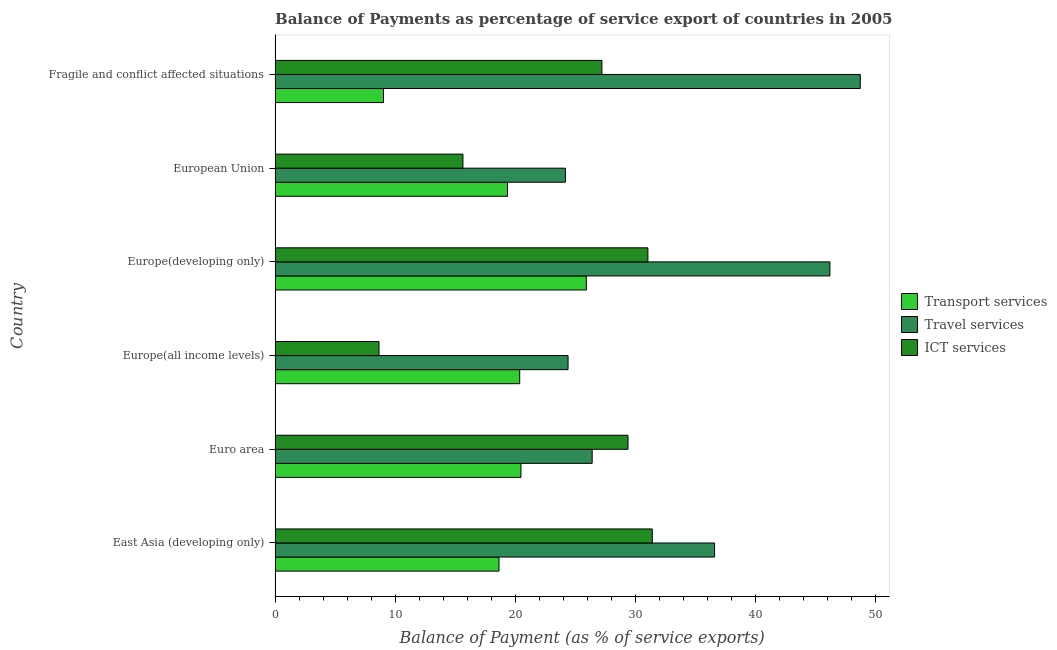How many different coloured bars are there?
Offer a very short reply. 3. How many groups of bars are there?
Give a very brief answer. 6. How many bars are there on the 4th tick from the top?
Your answer should be very brief. 3. How many bars are there on the 4th tick from the bottom?
Provide a short and direct response. 3. What is the label of the 4th group of bars from the top?
Your response must be concise. Europe(all income levels). What is the balance of payment of travel services in European Union?
Provide a succinct answer. 24.19. Across all countries, what is the maximum balance of payment of ict services?
Provide a short and direct response. 31.44. Across all countries, what is the minimum balance of payment of ict services?
Keep it short and to the point. 8.66. In which country was the balance of payment of travel services maximum?
Ensure brevity in your answer.  Fragile and conflict affected situations. In which country was the balance of payment of ict services minimum?
Your answer should be very brief. Europe(all income levels). What is the total balance of payment of transport services in the graph?
Your response must be concise. 113.88. What is the difference between the balance of payment of ict services in Euro area and that in Fragile and conflict affected situations?
Your response must be concise. 2.17. What is the difference between the balance of payment of ict services in Euro area and the balance of payment of travel services in Fragile and conflict affected situations?
Your answer should be very brief. -19.36. What is the average balance of payment of ict services per country?
Ensure brevity in your answer.  23.91. What is the difference between the balance of payment of ict services and balance of payment of transport services in Europe(developing only)?
Your response must be concise. 5.13. In how many countries, is the balance of payment of travel services greater than 10 %?
Ensure brevity in your answer.  6. What is the ratio of the balance of payment of ict services in Euro area to that in Fragile and conflict affected situations?
Offer a terse response. 1.08. Is the balance of payment of transport services in Euro area less than that in Fragile and conflict affected situations?
Keep it short and to the point. No. What is the difference between the highest and the second highest balance of payment of travel services?
Offer a very short reply. 2.53. What is the difference between the highest and the lowest balance of payment of ict services?
Offer a very short reply. 22.77. Is the sum of the balance of payment of travel services in Euro area and Fragile and conflict affected situations greater than the maximum balance of payment of ict services across all countries?
Make the answer very short. Yes. What does the 1st bar from the top in Europe(all income levels) represents?
Give a very brief answer. ICT services. What does the 1st bar from the bottom in Europe(all income levels) represents?
Keep it short and to the point. Transport services. Is it the case that in every country, the sum of the balance of payment of transport services and balance of payment of travel services is greater than the balance of payment of ict services?
Your response must be concise. Yes. Are all the bars in the graph horizontal?
Your answer should be very brief. Yes. What is the difference between two consecutive major ticks on the X-axis?
Your answer should be very brief. 10. Does the graph contain any zero values?
Provide a short and direct response. No. Where does the legend appear in the graph?
Your answer should be compact. Center right. How many legend labels are there?
Your response must be concise. 3. How are the legend labels stacked?
Offer a terse response. Vertical. What is the title of the graph?
Your response must be concise. Balance of Payments as percentage of service export of countries in 2005. Does "Primary" appear as one of the legend labels in the graph?
Give a very brief answer. No. What is the label or title of the X-axis?
Give a very brief answer. Balance of Payment (as % of service exports). What is the Balance of Payment (as % of service exports) in Transport services in East Asia (developing only)?
Make the answer very short. 18.66. What is the Balance of Payment (as % of service exports) in Travel services in East Asia (developing only)?
Keep it short and to the point. 36.63. What is the Balance of Payment (as % of service exports) in ICT services in East Asia (developing only)?
Your answer should be very brief. 31.44. What is the Balance of Payment (as % of service exports) of Transport services in Euro area?
Ensure brevity in your answer.  20.49. What is the Balance of Payment (as % of service exports) in Travel services in Euro area?
Your response must be concise. 26.42. What is the Balance of Payment (as % of service exports) in ICT services in Euro area?
Your answer should be very brief. 29.41. What is the Balance of Payment (as % of service exports) in Transport services in Europe(all income levels)?
Your response must be concise. 20.39. What is the Balance of Payment (as % of service exports) in Travel services in Europe(all income levels)?
Provide a short and direct response. 24.41. What is the Balance of Payment (as % of service exports) of ICT services in Europe(all income levels)?
Offer a very short reply. 8.66. What is the Balance of Payment (as % of service exports) in Transport services in Europe(developing only)?
Your answer should be compact. 25.94. What is the Balance of Payment (as % of service exports) in Travel services in Europe(developing only)?
Offer a very short reply. 46.24. What is the Balance of Payment (as % of service exports) of ICT services in Europe(developing only)?
Make the answer very short. 31.07. What is the Balance of Payment (as % of service exports) in Transport services in European Union?
Keep it short and to the point. 19.37. What is the Balance of Payment (as % of service exports) of Travel services in European Union?
Your answer should be very brief. 24.19. What is the Balance of Payment (as % of service exports) in ICT services in European Union?
Ensure brevity in your answer.  15.66. What is the Balance of Payment (as % of service exports) of Transport services in Fragile and conflict affected situations?
Give a very brief answer. 9.03. What is the Balance of Payment (as % of service exports) of Travel services in Fragile and conflict affected situations?
Your answer should be compact. 48.77. What is the Balance of Payment (as % of service exports) of ICT services in Fragile and conflict affected situations?
Your answer should be very brief. 27.24. Across all countries, what is the maximum Balance of Payment (as % of service exports) in Transport services?
Make the answer very short. 25.94. Across all countries, what is the maximum Balance of Payment (as % of service exports) of Travel services?
Provide a short and direct response. 48.77. Across all countries, what is the maximum Balance of Payment (as % of service exports) in ICT services?
Your answer should be compact. 31.44. Across all countries, what is the minimum Balance of Payment (as % of service exports) in Transport services?
Your answer should be very brief. 9.03. Across all countries, what is the minimum Balance of Payment (as % of service exports) in Travel services?
Your answer should be compact. 24.19. Across all countries, what is the minimum Balance of Payment (as % of service exports) in ICT services?
Your response must be concise. 8.66. What is the total Balance of Payment (as % of service exports) in Transport services in the graph?
Keep it short and to the point. 113.88. What is the total Balance of Payment (as % of service exports) of Travel services in the graph?
Your response must be concise. 206.66. What is the total Balance of Payment (as % of service exports) of ICT services in the graph?
Provide a succinct answer. 143.47. What is the difference between the Balance of Payment (as % of service exports) of Transport services in East Asia (developing only) and that in Euro area?
Ensure brevity in your answer.  -1.83. What is the difference between the Balance of Payment (as % of service exports) in Travel services in East Asia (developing only) and that in Euro area?
Make the answer very short. 10.2. What is the difference between the Balance of Payment (as % of service exports) in ICT services in East Asia (developing only) and that in Euro area?
Ensure brevity in your answer.  2.03. What is the difference between the Balance of Payment (as % of service exports) of Transport services in East Asia (developing only) and that in Europe(all income levels)?
Give a very brief answer. -1.72. What is the difference between the Balance of Payment (as % of service exports) of Travel services in East Asia (developing only) and that in Europe(all income levels)?
Your answer should be compact. 12.21. What is the difference between the Balance of Payment (as % of service exports) in ICT services in East Asia (developing only) and that in Europe(all income levels)?
Make the answer very short. 22.77. What is the difference between the Balance of Payment (as % of service exports) of Transport services in East Asia (developing only) and that in Europe(developing only)?
Offer a very short reply. -7.27. What is the difference between the Balance of Payment (as % of service exports) of Travel services in East Asia (developing only) and that in Europe(developing only)?
Give a very brief answer. -9.61. What is the difference between the Balance of Payment (as % of service exports) of ICT services in East Asia (developing only) and that in Europe(developing only)?
Provide a succinct answer. 0.37. What is the difference between the Balance of Payment (as % of service exports) of Transport services in East Asia (developing only) and that in European Union?
Offer a very short reply. -0.71. What is the difference between the Balance of Payment (as % of service exports) in Travel services in East Asia (developing only) and that in European Union?
Your answer should be compact. 12.43. What is the difference between the Balance of Payment (as % of service exports) in ICT services in East Asia (developing only) and that in European Union?
Give a very brief answer. 15.78. What is the difference between the Balance of Payment (as % of service exports) of Transport services in East Asia (developing only) and that in Fragile and conflict affected situations?
Provide a succinct answer. 9.63. What is the difference between the Balance of Payment (as % of service exports) of Travel services in East Asia (developing only) and that in Fragile and conflict affected situations?
Your answer should be compact. -12.14. What is the difference between the Balance of Payment (as % of service exports) of ICT services in East Asia (developing only) and that in Fragile and conflict affected situations?
Offer a terse response. 4.2. What is the difference between the Balance of Payment (as % of service exports) of Transport services in Euro area and that in Europe(all income levels)?
Ensure brevity in your answer.  0.11. What is the difference between the Balance of Payment (as % of service exports) of Travel services in Euro area and that in Europe(all income levels)?
Your response must be concise. 2.01. What is the difference between the Balance of Payment (as % of service exports) of ICT services in Euro area and that in Europe(all income levels)?
Provide a short and direct response. 20.75. What is the difference between the Balance of Payment (as % of service exports) in Transport services in Euro area and that in Europe(developing only)?
Provide a short and direct response. -5.45. What is the difference between the Balance of Payment (as % of service exports) in Travel services in Euro area and that in Europe(developing only)?
Give a very brief answer. -19.81. What is the difference between the Balance of Payment (as % of service exports) of ICT services in Euro area and that in Europe(developing only)?
Your response must be concise. -1.66. What is the difference between the Balance of Payment (as % of service exports) in Transport services in Euro area and that in European Union?
Your answer should be very brief. 1.12. What is the difference between the Balance of Payment (as % of service exports) of Travel services in Euro area and that in European Union?
Make the answer very short. 2.23. What is the difference between the Balance of Payment (as % of service exports) of ICT services in Euro area and that in European Union?
Give a very brief answer. 13.75. What is the difference between the Balance of Payment (as % of service exports) in Transport services in Euro area and that in Fragile and conflict affected situations?
Your response must be concise. 11.46. What is the difference between the Balance of Payment (as % of service exports) of Travel services in Euro area and that in Fragile and conflict affected situations?
Your answer should be very brief. -22.34. What is the difference between the Balance of Payment (as % of service exports) of ICT services in Euro area and that in Fragile and conflict affected situations?
Make the answer very short. 2.17. What is the difference between the Balance of Payment (as % of service exports) of Transport services in Europe(all income levels) and that in Europe(developing only)?
Offer a terse response. -5.55. What is the difference between the Balance of Payment (as % of service exports) in Travel services in Europe(all income levels) and that in Europe(developing only)?
Give a very brief answer. -21.82. What is the difference between the Balance of Payment (as % of service exports) of ICT services in Europe(all income levels) and that in Europe(developing only)?
Your answer should be compact. -22.41. What is the difference between the Balance of Payment (as % of service exports) of Transport services in Europe(all income levels) and that in European Union?
Make the answer very short. 1.01. What is the difference between the Balance of Payment (as % of service exports) of Travel services in Europe(all income levels) and that in European Union?
Provide a short and direct response. 0.22. What is the difference between the Balance of Payment (as % of service exports) in ICT services in Europe(all income levels) and that in European Union?
Provide a succinct answer. -6.99. What is the difference between the Balance of Payment (as % of service exports) in Transport services in Europe(all income levels) and that in Fragile and conflict affected situations?
Offer a terse response. 11.35. What is the difference between the Balance of Payment (as % of service exports) of Travel services in Europe(all income levels) and that in Fragile and conflict affected situations?
Your answer should be compact. -24.35. What is the difference between the Balance of Payment (as % of service exports) in ICT services in Europe(all income levels) and that in Fragile and conflict affected situations?
Offer a very short reply. -18.57. What is the difference between the Balance of Payment (as % of service exports) in Transport services in Europe(developing only) and that in European Union?
Keep it short and to the point. 6.56. What is the difference between the Balance of Payment (as % of service exports) of Travel services in Europe(developing only) and that in European Union?
Make the answer very short. 22.04. What is the difference between the Balance of Payment (as % of service exports) of ICT services in Europe(developing only) and that in European Union?
Offer a very short reply. 15.41. What is the difference between the Balance of Payment (as % of service exports) of Transport services in Europe(developing only) and that in Fragile and conflict affected situations?
Your answer should be very brief. 16.9. What is the difference between the Balance of Payment (as % of service exports) in Travel services in Europe(developing only) and that in Fragile and conflict affected situations?
Your response must be concise. -2.53. What is the difference between the Balance of Payment (as % of service exports) of ICT services in Europe(developing only) and that in Fragile and conflict affected situations?
Your answer should be very brief. 3.83. What is the difference between the Balance of Payment (as % of service exports) of Transport services in European Union and that in Fragile and conflict affected situations?
Your response must be concise. 10.34. What is the difference between the Balance of Payment (as % of service exports) in Travel services in European Union and that in Fragile and conflict affected situations?
Offer a very short reply. -24.57. What is the difference between the Balance of Payment (as % of service exports) of ICT services in European Union and that in Fragile and conflict affected situations?
Make the answer very short. -11.58. What is the difference between the Balance of Payment (as % of service exports) of Transport services in East Asia (developing only) and the Balance of Payment (as % of service exports) of Travel services in Euro area?
Your answer should be compact. -7.76. What is the difference between the Balance of Payment (as % of service exports) of Transport services in East Asia (developing only) and the Balance of Payment (as % of service exports) of ICT services in Euro area?
Offer a very short reply. -10.75. What is the difference between the Balance of Payment (as % of service exports) of Travel services in East Asia (developing only) and the Balance of Payment (as % of service exports) of ICT services in Euro area?
Keep it short and to the point. 7.22. What is the difference between the Balance of Payment (as % of service exports) in Transport services in East Asia (developing only) and the Balance of Payment (as % of service exports) in Travel services in Europe(all income levels)?
Provide a short and direct response. -5.75. What is the difference between the Balance of Payment (as % of service exports) of Transport services in East Asia (developing only) and the Balance of Payment (as % of service exports) of ICT services in Europe(all income levels)?
Ensure brevity in your answer.  10. What is the difference between the Balance of Payment (as % of service exports) in Travel services in East Asia (developing only) and the Balance of Payment (as % of service exports) in ICT services in Europe(all income levels)?
Your response must be concise. 27.96. What is the difference between the Balance of Payment (as % of service exports) of Transport services in East Asia (developing only) and the Balance of Payment (as % of service exports) of Travel services in Europe(developing only)?
Offer a very short reply. -27.57. What is the difference between the Balance of Payment (as % of service exports) of Transport services in East Asia (developing only) and the Balance of Payment (as % of service exports) of ICT services in Europe(developing only)?
Offer a very short reply. -12.41. What is the difference between the Balance of Payment (as % of service exports) in Travel services in East Asia (developing only) and the Balance of Payment (as % of service exports) in ICT services in Europe(developing only)?
Offer a terse response. 5.56. What is the difference between the Balance of Payment (as % of service exports) of Transport services in East Asia (developing only) and the Balance of Payment (as % of service exports) of Travel services in European Union?
Offer a very short reply. -5.53. What is the difference between the Balance of Payment (as % of service exports) in Transport services in East Asia (developing only) and the Balance of Payment (as % of service exports) in ICT services in European Union?
Ensure brevity in your answer.  3.01. What is the difference between the Balance of Payment (as % of service exports) of Travel services in East Asia (developing only) and the Balance of Payment (as % of service exports) of ICT services in European Union?
Your response must be concise. 20.97. What is the difference between the Balance of Payment (as % of service exports) in Transport services in East Asia (developing only) and the Balance of Payment (as % of service exports) in Travel services in Fragile and conflict affected situations?
Give a very brief answer. -30.11. What is the difference between the Balance of Payment (as % of service exports) of Transport services in East Asia (developing only) and the Balance of Payment (as % of service exports) of ICT services in Fragile and conflict affected situations?
Give a very brief answer. -8.57. What is the difference between the Balance of Payment (as % of service exports) of Travel services in East Asia (developing only) and the Balance of Payment (as % of service exports) of ICT services in Fragile and conflict affected situations?
Your answer should be compact. 9.39. What is the difference between the Balance of Payment (as % of service exports) in Transport services in Euro area and the Balance of Payment (as % of service exports) in Travel services in Europe(all income levels)?
Offer a terse response. -3.92. What is the difference between the Balance of Payment (as % of service exports) in Transport services in Euro area and the Balance of Payment (as % of service exports) in ICT services in Europe(all income levels)?
Keep it short and to the point. 11.83. What is the difference between the Balance of Payment (as % of service exports) of Travel services in Euro area and the Balance of Payment (as % of service exports) of ICT services in Europe(all income levels)?
Offer a terse response. 17.76. What is the difference between the Balance of Payment (as % of service exports) of Transport services in Euro area and the Balance of Payment (as % of service exports) of Travel services in Europe(developing only)?
Offer a terse response. -25.75. What is the difference between the Balance of Payment (as % of service exports) of Transport services in Euro area and the Balance of Payment (as % of service exports) of ICT services in Europe(developing only)?
Your response must be concise. -10.58. What is the difference between the Balance of Payment (as % of service exports) of Travel services in Euro area and the Balance of Payment (as % of service exports) of ICT services in Europe(developing only)?
Your answer should be compact. -4.64. What is the difference between the Balance of Payment (as % of service exports) in Transport services in Euro area and the Balance of Payment (as % of service exports) in Travel services in European Union?
Provide a succinct answer. -3.7. What is the difference between the Balance of Payment (as % of service exports) in Transport services in Euro area and the Balance of Payment (as % of service exports) in ICT services in European Union?
Offer a terse response. 4.84. What is the difference between the Balance of Payment (as % of service exports) in Travel services in Euro area and the Balance of Payment (as % of service exports) in ICT services in European Union?
Ensure brevity in your answer.  10.77. What is the difference between the Balance of Payment (as % of service exports) of Transport services in Euro area and the Balance of Payment (as % of service exports) of Travel services in Fragile and conflict affected situations?
Your answer should be compact. -28.28. What is the difference between the Balance of Payment (as % of service exports) in Transport services in Euro area and the Balance of Payment (as % of service exports) in ICT services in Fragile and conflict affected situations?
Offer a terse response. -6.74. What is the difference between the Balance of Payment (as % of service exports) in Travel services in Euro area and the Balance of Payment (as % of service exports) in ICT services in Fragile and conflict affected situations?
Ensure brevity in your answer.  -0.81. What is the difference between the Balance of Payment (as % of service exports) in Transport services in Europe(all income levels) and the Balance of Payment (as % of service exports) in Travel services in Europe(developing only)?
Keep it short and to the point. -25.85. What is the difference between the Balance of Payment (as % of service exports) in Transport services in Europe(all income levels) and the Balance of Payment (as % of service exports) in ICT services in Europe(developing only)?
Your answer should be very brief. -10.68. What is the difference between the Balance of Payment (as % of service exports) in Travel services in Europe(all income levels) and the Balance of Payment (as % of service exports) in ICT services in Europe(developing only)?
Offer a very short reply. -6.66. What is the difference between the Balance of Payment (as % of service exports) in Transport services in Europe(all income levels) and the Balance of Payment (as % of service exports) in Travel services in European Union?
Your answer should be compact. -3.81. What is the difference between the Balance of Payment (as % of service exports) of Transport services in Europe(all income levels) and the Balance of Payment (as % of service exports) of ICT services in European Union?
Provide a short and direct response. 4.73. What is the difference between the Balance of Payment (as % of service exports) in Travel services in Europe(all income levels) and the Balance of Payment (as % of service exports) in ICT services in European Union?
Make the answer very short. 8.76. What is the difference between the Balance of Payment (as % of service exports) in Transport services in Europe(all income levels) and the Balance of Payment (as % of service exports) in Travel services in Fragile and conflict affected situations?
Your answer should be very brief. -28.38. What is the difference between the Balance of Payment (as % of service exports) of Transport services in Europe(all income levels) and the Balance of Payment (as % of service exports) of ICT services in Fragile and conflict affected situations?
Your response must be concise. -6.85. What is the difference between the Balance of Payment (as % of service exports) of Travel services in Europe(all income levels) and the Balance of Payment (as % of service exports) of ICT services in Fragile and conflict affected situations?
Offer a terse response. -2.82. What is the difference between the Balance of Payment (as % of service exports) in Transport services in Europe(developing only) and the Balance of Payment (as % of service exports) in Travel services in European Union?
Keep it short and to the point. 1.74. What is the difference between the Balance of Payment (as % of service exports) of Transport services in Europe(developing only) and the Balance of Payment (as % of service exports) of ICT services in European Union?
Give a very brief answer. 10.28. What is the difference between the Balance of Payment (as % of service exports) in Travel services in Europe(developing only) and the Balance of Payment (as % of service exports) in ICT services in European Union?
Give a very brief answer. 30.58. What is the difference between the Balance of Payment (as % of service exports) of Transport services in Europe(developing only) and the Balance of Payment (as % of service exports) of Travel services in Fragile and conflict affected situations?
Make the answer very short. -22.83. What is the difference between the Balance of Payment (as % of service exports) of Transport services in Europe(developing only) and the Balance of Payment (as % of service exports) of ICT services in Fragile and conflict affected situations?
Your answer should be compact. -1.3. What is the difference between the Balance of Payment (as % of service exports) of Travel services in Europe(developing only) and the Balance of Payment (as % of service exports) of ICT services in Fragile and conflict affected situations?
Provide a short and direct response. 19. What is the difference between the Balance of Payment (as % of service exports) of Transport services in European Union and the Balance of Payment (as % of service exports) of Travel services in Fragile and conflict affected situations?
Make the answer very short. -29.4. What is the difference between the Balance of Payment (as % of service exports) of Transport services in European Union and the Balance of Payment (as % of service exports) of ICT services in Fragile and conflict affected situations?
Ensure brevity in your answer.  -7.86. What is the difference between the Balance of Payment (as % of service exports) in Travel services in European Union and the Balance of Payment (as % of service exports) in ICT services in Fragile and conflict affected situations?
Your response must be concise. -3.04. What is the average Balance of Payment (as % of service exports) of Transport services per country?
Offer a terse response. 18.98. What is the average Balance of Payment (as % of service exports) of Travel services per country?
Provide a short and direct response. 34.44. What is the average Balance of Payment (as % of service exports) of ICT services per country?
Keep it short and to the point. 23.91. What is the difference between the Balance of Payment (as % of service exports) of Transport services and Balance of Payment (as % of service exports) of Travel services in East Asia (developing only)?
Keep it short and to the point. -17.96. What is the difference between the Balance of Payment (as % of service exports) of Transport services and Balance of Payment (as % of service exports) of ICT services in East Asia (developing only)?
Your answer should be very brief. -12.77. What is the difference between the Balance of Payment (as % of service exports) of Travel services and Balance of Payment (as % of service exports) of ICT services in East Asia (developing only)?
Provide a succinct answer. 5.19. What is the difference between the Balance of Payment (as % of service exports) of Transport services and Balance of Payment (as % of service exports) of Travel services in Euro area?
Make the answer very short. -5.93. What is the difference between the Balance of Payment (as % of service exports) of Transport services and Balance of Payment (as % of service exports) of ICT services in Euro area?
Make the answer very short. -8.92. What is the difference between the Balance of Payment (as % of service exports) in Travel services and Balance of Payment (as % of service exports) in ICT services in Euro area?
Your answer should be very brief. -2.99. What is the difference between the Balance of Payment (as % of service exports) of Transport services and Balance of Payment (as % of service exports) of Travel services in Europe(all income levels)?
Your answer should be very brief. -4.03. What is the difference between the Balance of Payment (as % of service exports) in Transport services and Balance of Payment (as % of service exports) in ICT services in Europe(all income levels)?
Ensure brevity in your answer.  11.72. What is the difference between the Balance of Payment (as % of service exports) in Travel services and Balance of Payment (as % of service exports) in ICT services in Europe(all income levels)?
Offer a very short reply. 15.75. What is the difference between the Balance of Payment (as % of service exports) in Transport services and Balance of Payment (as % of service exports) in Travel services in Europe(developing only)?
Provide a succinct answer. -20.3. What is the difference between the Balance of Payment (as % of service exports) in Transport services and Balance of Payment (as % of service exports) in ICT services in Europe(developing only)?
Ensure brevity in your answer.  -5.13. What is the difference between the Balance of Payment (as % of service exports) of Travel services and Balance of Payment (as % of service exports) of ICT services in Europe(developing only)?
Your answer should be very brief. 15.17. What is the difference between the Balance of Payment (as % of service exports) in Transport services and Balance of Payment (as % of service exports) in Travel services in European Union?
Provide a succinct answer. -4.82. What is the difference between the Balance of Payment (as % of service exports) in Transport services and Balance of Payment (as % of service exports) in ICT services in European Union?
Your answer should be compact. 3.72. What is the difference between the Balance of Payment (as % of service exports) in Travel services and Balance of Payment (as % of service exports) in ICT services in European Union?
Provide a succinct answer. 8.54. What is the difference between the Balance of Payment (as % of service exports) in Transport services and Balance of Payment (as % of service exports) in Travel services in Fragile and conflict affected situations?
Give a very brief answer. -39.74. What is the difference between the Balance of Payment (as % of service exports) in Transport services and Balance of Payment (as % of service exports) in ICT services in Fragile and conflict affected situations?
Offer a very short reply. -18.2. What is the difference between the Balance of Payment (as % of service exports) in Travel services and Balance of Payment (as % of service exports) in ICT services in Fragile and conflict affected situations?
Your answer should be compact. 21.53. What is the ratio of the Balance of Payment (as % of service exports) in Transport services in East Asia (developing only) to that in Euro area?
Keep it short and to the point. 0.91. What is the ratio of the Balance of Payment (as % of service exports) of Travel services in East Asia (developing only) to that in Euro area?
Provide a short and direct response. 1.39. What is the ratio of the Balance of Payment (as % of service exports) of ICT services in East Asia (developing only) to that in Euro area?
Provide a succinct answer. 1.07. What is the ratio of the Balance of Payment (as % of service exports) of Transport services in East Asia (developing only) to that in Europe(all income levels)?
Your response must be concise. 0.92. What is the ratio of the Balance of Payment (as % of service exports) of Travel services in East Asia (developing only) to that in Europe(all income levels)?
Your answer should be compact. 1.5. What is the ratio of the Balance of Payment (as % of service exports) of ICT services in East Asia (developing only) to that in Europe(all income levels)?
Your answer should be compact. 3.63. What is the ratio of the Balance of Payment (as % of service exports) in Transport services in East Asia (developing only) to that in Europe(developing only)?
Make the answer very short. 0.72. What is the ratio of the Balance of Payment (as % of service exports) of Travel services in East Asia (developing only) to that in Europe(developing only)?
Make the answer very short. 0.79. What is the ratio of the Balance of Payment (as % of service exports) in ICT services in East Asia (developing only) to that in Europe(developing only)?
Give a very brief answer. 1.01. What is the ratio of the Balance of Payment (as % of service exports) in Transport services in East Asia (developing only) to that in European Union?
Give a very brief answer. 0.96. What is the ratio of the Balance of Payment (as % of service exports) of Travel services in East Asia (developing only) to that in European Union?
Offer a very short reply. 1.51. What is the ratio of the Balance of Payment (as % of service exports) of ICT services in East Asia (developing only) to that in European Union?
Your response must be concise. 2.01. What is the ratio of the Balance of Payment (as % of service exports) in Transport services in East Asia (developing only) to that in Fragile and conflict affected situations?
Give a very brief answer. 2.07. What is the ratio of the Balance of Payment (as % of service exports) in Travel services in East Asia (developing only) to that in Fragile and conflict affected situations?
Provide a succinct answer. 0.75. What is the ratio of the Balance of Payment (as % of service exports) in ICT services in East Asia (developing only) to that in Fragile and conflict affected situations?
Your response must be concise. 1.15. What is the ratio of the Balance of Payment (as % of service exports) in Transport services in Euro area to that in Europe(all income levels)?
Your answer should be compact. 1.01. What is the ratio of the Balance of Payment (as % of service exports) of Travel services in Euro area to that in Europe(all income levels)?
Provide a succinct answer. 1.08. What is the ratio of the Balance of Payment (as % of service exports) in ICT services in Euro area to that in Europe(all income levels)?
Give a very brief answer. 3.4. What is the ratio of the Balance of Payment (as % of service exports) of Transport services in Euro area to that in Europe(developing only)?
Ensure brevity in your answer.  0.79. What is the ratio of the Balance of Payment (as % of service exports) of Travel services in Euro area to that in Europe(developing only)?
Your answer should be very brief. 0.57. What is the ratio of the Balance of Payment (as % of service exports) of ICT services in Euro area to that in Europe(developing only)?
Provide a short and direct response. 0.95. What is the ratio of the Balance of Payment (as % of service exports) in Transport services in Euro area to that in European Union?
Your answer should be compact. 1.06. What is the ratio of the Balance of Payment (as % of service exports) in Travel services in Euro area to that in European Union?
Make the answer very short. 1.09. What is the ratio of the Balance of Payment (as % of service exports) of ICT services in Euro area to that in European Union?
Offer a terse response. 1.88. What is the ratio of the Balance of Payment (as % of service exports) of Transport services in Euro area to that in Fragile and conflict affected situations?
Keep it short and to the point. 2.27. What is the ratio of the Balance of Payment (as % of service exports) of Travel services in Euro area to that in Fragile and conflict affected situations?
Your answer should be compact. 0.54. What is the ratio of the Balance of Payment (as % of service exports) of ICT services in Euro area to that in Fragile and conflict affected situations?
Ensure brevity in your answer.  1.08. What is the ratio of the Balance of Payment (as % of service exports) of Transport services in Europe(all income levels) to that in Europe(developing only)?
Your response must be concise. 0.79. What is the ratio of the Balance of Payment (as % of service exports) in Travel services in Europe(all income levels) to that in Europe(developing only)?
Make the answer very short. 0.53. What is the ratio of the Balance of Payment (as % of service exports) of ICT services in Europe(all income levels) to that in Europe(developing only)?
Ensure brevity in your answer.  0.28. What is the ratio of the Balance of Payment (as % of service exports) of Transport services in Europe(all income levels) to that in European Union?
Your answer should be compact. 1.05. What is the ratio of the Balance of Payment (as % of service exports) in Travel services in Europe(all income levels) to that in European Union?
Provide a short and direct response. 1.01. What is the ratio of the Balance of Payment (as % of service exports) in ICT services in Europe(all income levels) to that in European Union?
Keep it short and to the point. 0.55. What is the ratio of the Balance of Payment (as % of service exports) of Transport services in Europe(all income levels) to that in Fragile and conflict affected situations?
Ensure brevity in your answer.  2.26. What is the ratio of the Balance of Payment (as % of service exports) in Travel services in Europe(all income levels) to that in Fragile and conflict affected situations?
Offer a terse response. 0.5. What is the ratio of the Balance of Payment (as % of service exports) in ICT services in Europe(all income levels) to that in Fragile and conflict affected situations?
Offer a terse response. 0.32. What is the ratio of the Balance of Payment (as % of service exports) of Transport services in Europe(developing only) to that in European Union?
Provide a short and direct response. 1.34. What is the ratio of the Balance of Payment (as % of service exports) in Travel services in Europe(developing only) to that in European Union?
Your answer should be compact. 1.91. What is the ratio of the Balance of Payment (as % of service exports) of ICT services in Europe(developing only) to that in European Union?
Offer a very short reply. 1.98. What is the ratio of the Balance of Payment (as % of service exports) in Transport services in Europe(developing only) to that in Fragile and conflict affected situations?
Provide a succinct answer. 2.87. What is the ratio of the Balance of Payment (as % of service exports) in Travel services in Europe(developing only) to that in Fragile and conflict affected situations?
Offer a very short reply. 0.95. What is the ratio of the Balance of Payment (as % of service exports) in ICT services in Europe(developing only) to that in Fragile and conflict affected situations?
Your answer should be very brief. 1.14. What is the ratio of the Balance of Payment (as % of service exports) of Transport services in European Union to that in Fragile and conflict affected situations?
Make the answer very short. 2.14. What is the ratio of the Balance of Payment (as % of service exports) in Travel services in European Union to that in Fragile and conflict affected situations?
Offer a terse response. 0.5. What is the ratio of the Balance of Payment (as % of service exports) of ICT services in European Union to that in Fragile and conflict affected situations?
Offer a very short reply. 0.57. What is the difference between the highest and the second highest Balance of Payment (as % of service exports) of Transport services?
Your response must be concise. 5.45. What is the difference between the highest and the second highest Balance of Payment (as % of service exports) in Travel services?
Provide a short and direct response. 2.53. What is the difference between the highest and the second highest Balance of Payment (as % of service exports) in ICT services?
Your answer should be compact. 0.37. What is the difference between the highest and the lowest Balance of Payment (as % of service exports) in Transport services?
Offer a very short reply. 16.9. What is the difference between the highest and the lowest Balance of Payment (as % of service exports) in Travel services?
Make the answer very short. 24.57. What is the difference between the highest and the lowest Balance of Payment (as % of service exports) of ICT services?
Provide a succinct answer. 22.77. 